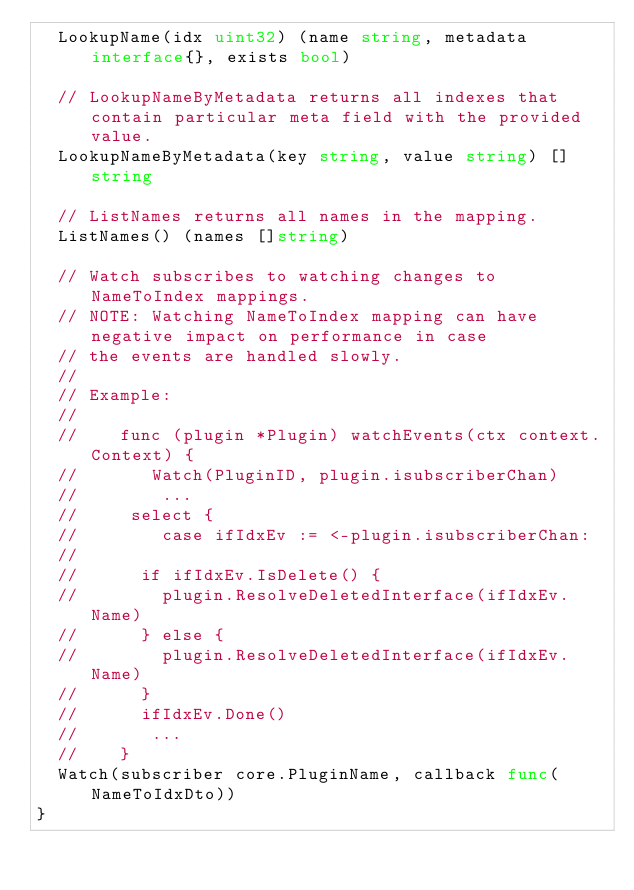<code> <loc_0><loc_0><loc_500><loc_500><_Go_>	LookupName(idx uint32) (name string, metadata interface{}, exists bool)

	// LookupNameByMetadata returns all indexes that contain particular meta field with the provided value.
	LookupNameByMetadata(key string, value string) []string

	// ListNames returns all names in the mapping.
	ListNames() (names []string)

	// Watch subscribes to watching changes to NameToIndex mappings.
	// NOTE: Watching NameToIndex mapping can have negative impact on performance in case
	// the events are handled slowly.
	//
	// Example:
	//
	//    func (plugin *Plugin) watchEvents(ctx context.Context) {
	//       Watch(PluginID, plugin.isubscriberChan)
	//        ...
	//		 select {
	// 		    case ifIdxEv := <-plugin.isubscriberChan:
	//
	//			if ifIdxEv.IsDelete() {
	//				plugin.ResolveDeletedInterface(ifIdxEv.Name)
	//			} else {
	//				plugin.ResolveDeletedInterface(ifIdxEv.Name)
	//			}
	//			ifIdxEv.Done()
	//       ...
	//    }
	Watch(subscriber core.PluginName, callback func(NameToIdxDto))
}
</code> 